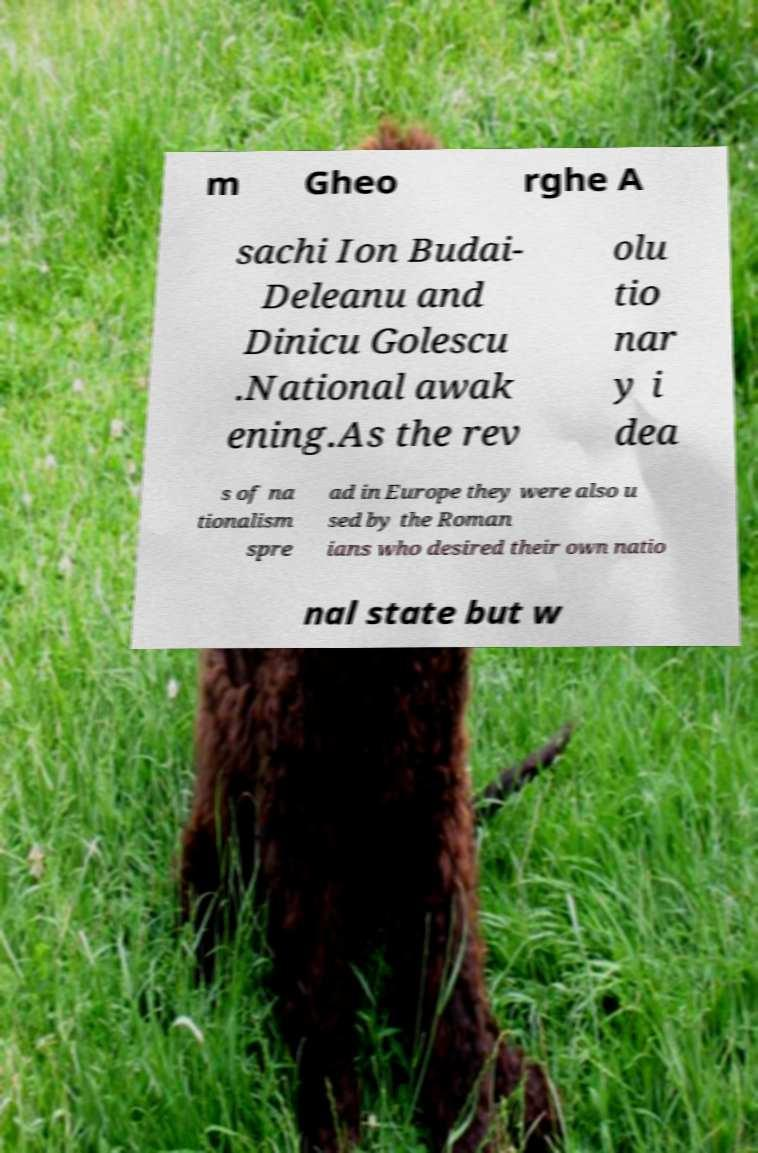Could you extract and type out the text from this image? m Gheo rghe A sachi Ion Budai- Deleanu and Dinicu Golescu .National awak ening.As the rev olu tio nar y i dea s of na tionalism spre ad in Europe they were also u sed by the Roman ians who desired their own natio nal state but w 